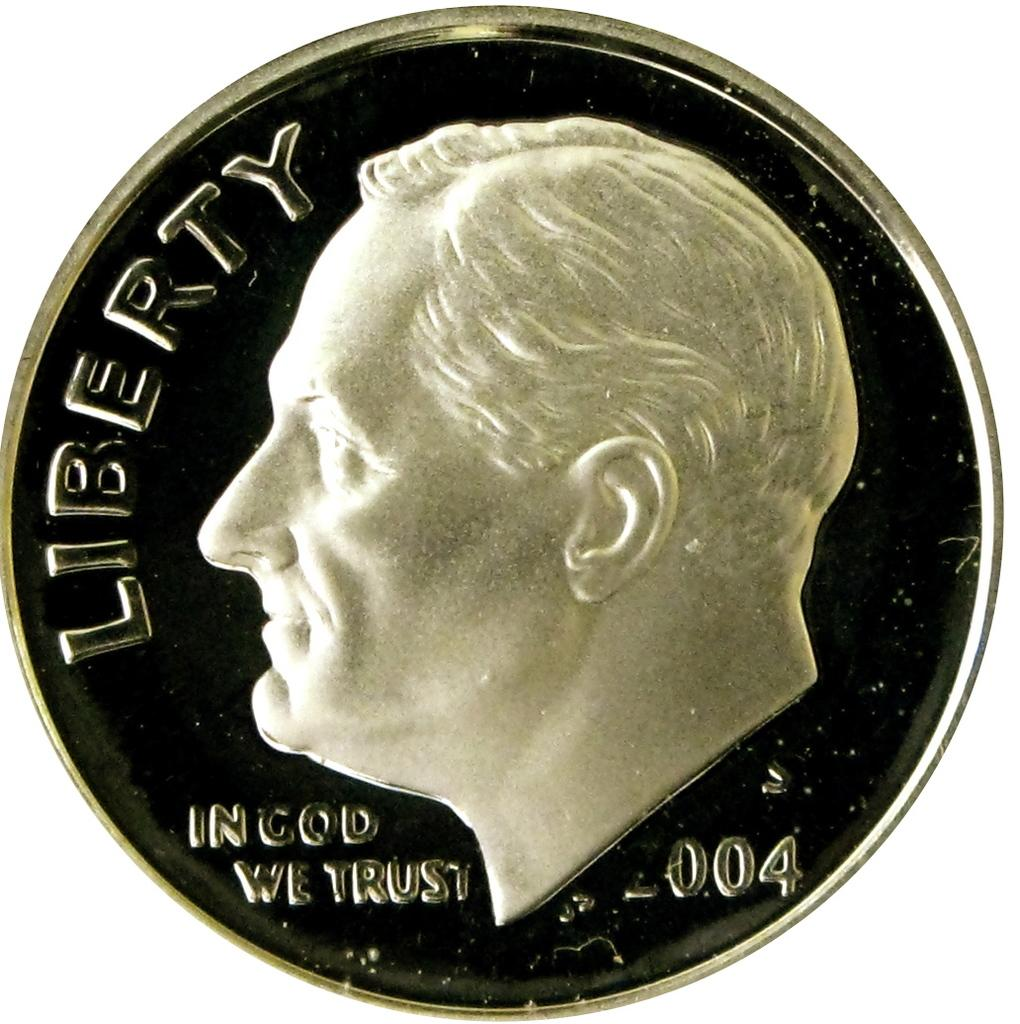Provide a one-sentence caption for the provided image. The silver coin shown states that In God We Trust. 